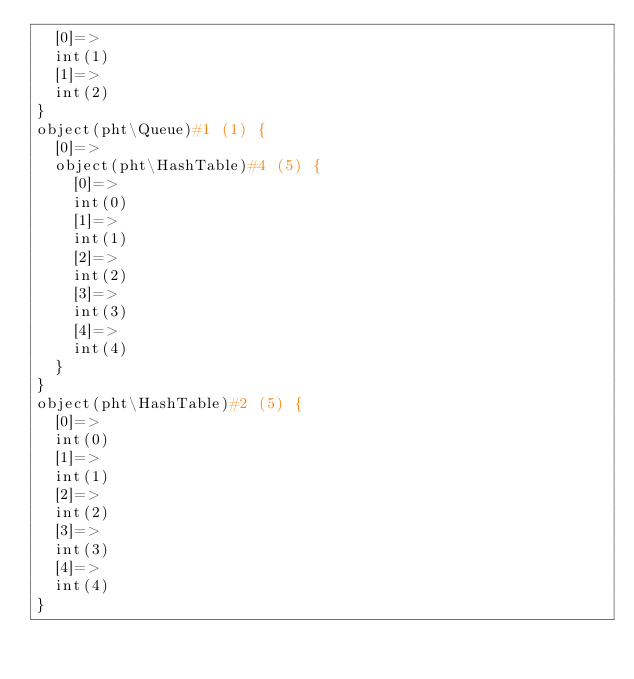Convert code to text. <code><loc_0><loc_0><loc_500><loc_500><_PHP_>  [0]=>
  int(1)
  [1]=>
  int(2)
}
object(pht\Queue)#1 (1) {
  [0]=>
  object(pht\HashTable)#4 (5) {
    [0]=>
    int(0)
    [1]=>
    int(1)
    [2]=>
    int(2)
    [3]=>
    int(3)
    [4]=>
    int(4)
  }
}
object(pht\HashTable)#2 (5) {
  [0]=>
  int(0)
  [1]=>
  int(1)
  [2]=>
  int(2)
  [3]=>
  int(3)
  [4]=>
  int(4)
}
</code> 